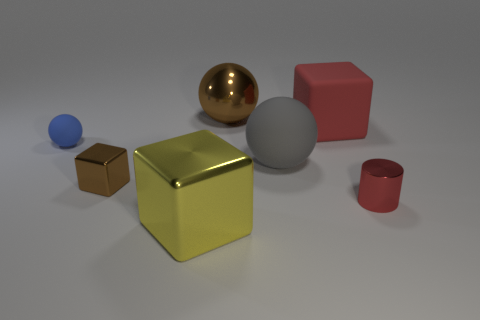What is the material of the small cylinder that is the same color as the rubber cube?
Provide a short and direct response. Metal. Is the material of the big red thing the same as the red cylinder?
Ensure brevity in your answer.  No. What number of green cylinders have the same material as the gray sphere?
Your response must be concise. 0. There is a cube that is made of the same material as the small blue ball; what is its color?
Give a very brief answer. Red. What is the shape of the tiny red metallic object?
Your answer should be compact. Cylinder. There is a red thing behind the tiny red thing; what is it made of?
Offer a very short reply. Rubber. Is there a small metal thing of the same color as the large matte cube?
Provide a short and direct response. Yes. There is a shiny object that is the same size as the shiny cylinder; what is its shape?
Ensure brevity in your answer.  Cube. There is a metal thing right of the gray sphere; what is its color?
Provide a short and direct response. Red. There is a big thing on the right side of the gray rubber sphere; is there a thing behind it?
Offer a terse response. Yes. 